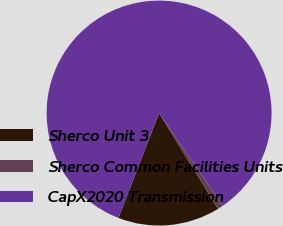<chart> <loc_0><loc_0><loc_500><loc_500><pie_chart><fcel>Sherco Unit 3<fcel>Sherco Common Facilities Units<fcel>CapX2020 Transmission<nl><fcel>14.66%<fcel>0.81%<fcel>84.53%<nl></chart> 